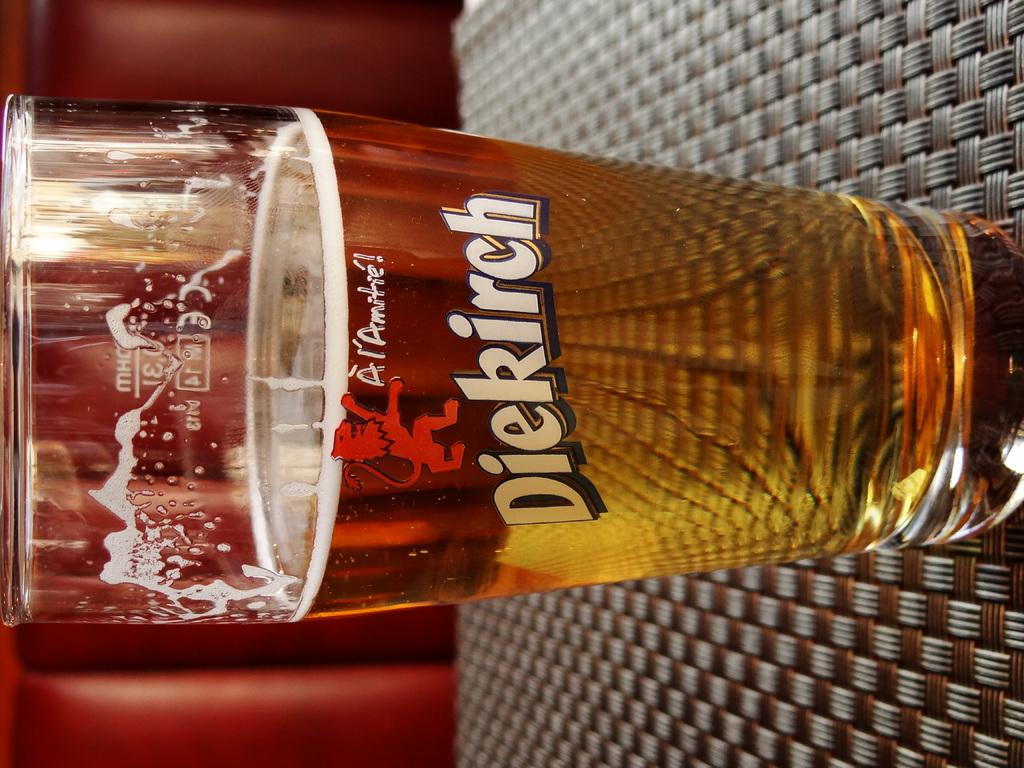What is in the glass that is visible in the image? The glass contains liquid and foam. What is the glass placed on in the image? The glass is placed on a surface. What color is the background of the image? The background of the image is red. How many cherries can be seen on the brick in the image? There is no brick or cherries present in the image. 